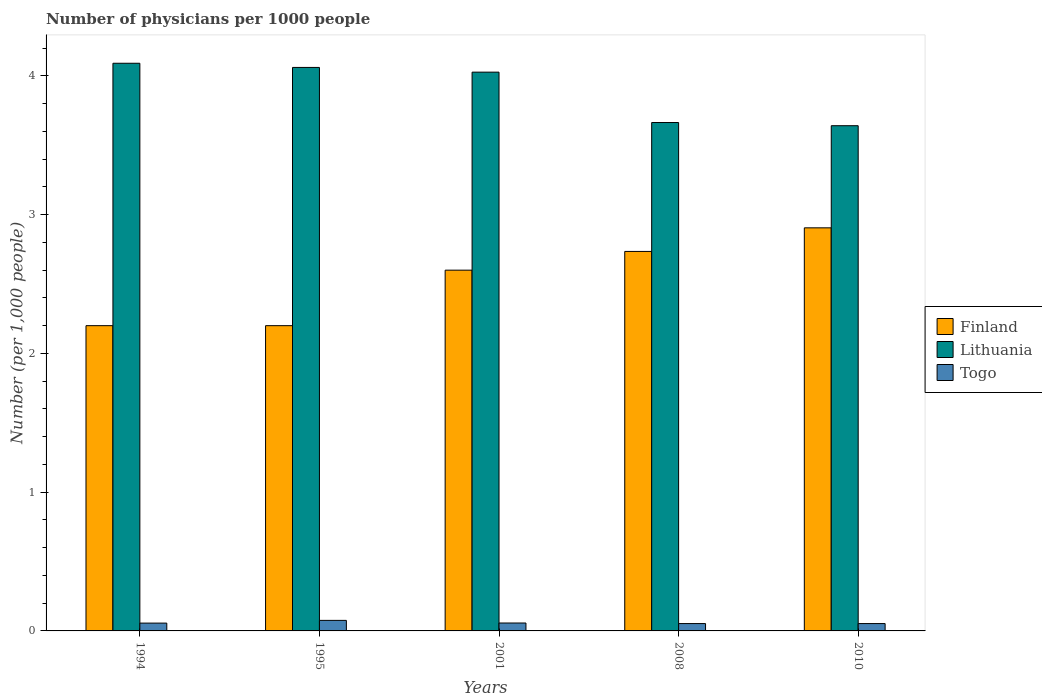How many different coloured bars are there?
Offer a terse response. 3. How many groups of bars are there?
Provide a succinct answer. 5. How many bars are there on the 2nd tick from the right?
Make the answer very short. 3. What is the label of the 4th group of bars from the left?
Keep it short and to the point. 2008. What is the number of physicians in Finland in 2008?
Give a very brief answer. 2.73. Across all years, what is the maximum number of physicians in Finland?
Your response must be concise. 2.9. In which year was the number of physicians in Finland minimum?
Provide a short and direct response. 1994. What is the total number of physicians in Finland in the graph?
Your answer should be compact. 12.64. What is the difference between the number of physicians in Togo in 1995 and that in 2008?
Make the answer very short. 0.02. What is the difference between the number of physicians in Lithuania in 2010 and the number of physicians in Finland in 1995?
Offer a very short reply. 1.44. What is the average number of physicians in Lithuania per year?
Offer a very short reply. 3.9. In the year 2010, what is the difference between the number of physicians in Finland and number of physicians in Lithuania?
Your answer should be very brief. -0.74. What is the ratio of the number of physicians in Finland in 1994 to that in 2001?
Provide a short and direct response. 0.85. What is the difference between the highest and the second highest number of physicians in Finland?
Make the answer very short. 0.17. What is the difference between the highest and the lowest number of physicians in Finland?
Ensure brevity in your answer.  0.7. In how many years, is the number of physicians in Lithuania greater than the average number of physicians in Lithuania taken over all years?
Offer a very short reply. 3. What does the 2nd bar from the left in 2001 represents?
Make the answer very short. Lithuania. Is it the case that in every year, the sum of the number of physicians in Finland and number of physicians in Togo is greater than the number of physicians in Lithuania?
Offer a very short reply. No. Does the graph contain any zero values?
Your answer should be compact. No. Where does the legend appear in the graph?
Make the answer very short. Center right. What is the title of the graph?
Your response must be concise. Number of physicians per 1000 people. What is the label or title of the Y-axis?
Offer a terse response. Number (per 1,0 people). What is the Number (per 1,000 people) in Finland in 1994?
Provide a short and direct response. 2.2. What is the Number (per 1,000 people) in Lithuania in 1994?
Give a very brief answer. 4.09. What is the Number (per 1,000 people) in Togo in 1994?
Keep it short and to the point. 0.06. What is the Number (per 1,000 people) in Lithuania in 1995?
Offer a very short reply. 4.06. What is the Number (per 1,000 people) of Togo in 1995?
Make the answer very short. 0.08. What is the Number (per 1,000 people) of Lithuania in 2001?
Your answer should be very brief. 4.03. What is the Number (per 1,000 people) in Togo in 2001?
Make the answer very short. 0.06. What is the Number (per 1,000 people) of Finland in 2008?
Provide a succinct answer. 2.73. What is the Number (per 1,000 people) of Lithuania in 2008?
Offer a very short reply. 3.66. What is the Number (per 1,000 people) of Togo in 2008?
Offer a very short reply. 0.05. What is the Number (per 1,000 people) in Finland in 2010?
Provide a short and direct response. 2.9. What is the Number (per 1,000 people) in Lithuania in 2010?
Your answer should be compact. 3.64. What is the Number (per 1,000 people) in Togo in 2010?
Ensure brevity in your answer.  0.05. Across all years, what is the maximum Number (per 1,000 people) of Finland?
Make the answer very short. 2.9. Across all years, what is the maximum Number (per 1,000 people) of Lithuania?
Give a very brief answer. 4.09. Across all years, what is the maximum Number (per 1,000 people) of Togo?
Your answer should be compact. 0.08. Across all years, what is the minimum Number (per 1,000 people) of Finland?
Your answer should be compact. 2.2. Across all years, what is the minimum Number (per 1,000 people) of Lithuania?
Provide a short and direct response. 3.64. Across all years, what is the minimum Number (per 1,000 people) of Togo?
Ensure brevity in your answer.  0.05. What is the total Number (per 1,000 people) of Finland in the graph?
Your response must be concise. 12.64. What is the total Number (per 1,000 people) of Lithuania in the graph?
Provide a succinct answer. 19.48. What is the total Number (per 1,000 people) in Togo in the graph?
Make the answer very short. 0.3. What is the difference between the Number (per 1,000 people) in Lithuania in 1994 and that in 1995?
Your response must be concise. 0.03. What is the difference between the Number (per 1,000 people) in Togo in 1994 and that in 1995?
Keep it short and to the point. -0.02. What is the difference between the Number (per 1,000 people) in Lithuania in 1994 and that in 2001?
Offer a very short reply. 0.06. What is the difference between the Number (per 1,000 people) in Togo in 1994 and that in 2001?
Offer a terse response. -0. What is the difference between the Number (per 1,000 people) of Finland in 1994 and that in 2008?
Your answer should be very brief. -0.54. What is the difference between the Number (per 1,000 people) in Lithuania in 1994 and that in 2008?
Ensure brevity in your answer.  0.43. What is the difference between the Number (per 1,000 people) of Togo in 1994 and that in 2008?
Provide a short and direct response. 0. What is the difference between the Number (per 1,000 people) of Finland in 1994 and that in 2010?
Provide a short and direct response. -0.7. What is the difference between the Number (per 1,000 people) of Lithuania in 1994 and that in 2010?
Provide a short and direct response. 0.45. What is the difference between the Number (per 1,000 people) in Togo in 1994 and that in 2010?
Make the answer very short. 0. What is the difference between the Number (per 1,000 people) in Finland in 1995 and that in 2001?
Make the answer very short. -0.4. What is the difference between the Number (per 1,000 people) in Lithuania in 1995 and that in 2001?
Provide a succinct answer. 0.03. What is the difference between the Number (per 1,000 people) in Togo in 1995 and that in 2001?
Give a very brief answer. 0.02. What is the difference between the Number (per 1,000 people) of Finland in 1995 and that in 2008?
Offer a very short reply. -0.54. What is the difference between the Number (per 1,000 people) in Lithuania in 1995 and that in 2008?
Offer a terse response. 0.4. What is the difference between the Number (per 1,000 people) in Togo in 1995 and that in 2008?
Make the answer very short. 0.02. What is the difference between the Number (per 1,000 people) of Finland in 1995 and that in 2010?
Make the answer very short. -0.7. What is the difference between the Number (per 1,000 people) of Lithuania in 1995 and that in 2010?
Offer a terse response. 0.42. What is the difference between the Number (per 1,000 people) of Togo in 1995 and that in 2010?
Provide a succinct answer. 0.02. What is the difference between the Number (per 1,000 people) in Finland in 2001 and that in 2008?
Your answer should be compact. -0.14. What is the difference between the Number (per 1,000 people) in Lithuania in 2001 and that in 2008?
Give a very brief answer. 0.36. What is the difference between the Number (per 1,000 people) in Togo in 2001 and that in 2008?
Your response must be concise. 0. What is the difference between the Number (per 1,000 people) in Finland in 2001 and that in 2010?
Your answer should be very brief. -0.3. What is the difference between the Number (per 1,000 people) in Lithuania in 2001 and that in 2010?
Your response must be concise. 0.39. What is the difference between the Number (per 1,000 people) in Togo in 2001 and that in 2010?
Keep it short and to the point. 0. What is the difference between the Number (per 1,000 people) of Finland in 2008 and that in 2010?
Give a very brief answer. -0.17. What is the difference between the Number (per 1,000 people) of Lithuania in 2008 and that in 2010?
Offer a very short reply. 0.02. What is the difference between the Number (per 1,000 people) of Finland in 1994 and the Number (per 1,000 people) of Lithuania in 1995?
Your answer should be very brief. -1.86. What is the difference between the Number (per 1,000 people) in Finland in 1994 and the Number (per 1,000 people) in Togo in 1995?
Ensure brevity in your answer.  2.12. What is the difference between the Number (per 1,000 people) in Lithuania in 1994 and the Number (per 1,000 people) in Togo in 1995?
Your answer should be very brief. 4.02. What is the difference between the Number (per 1,000 people) in Finland in 1994 and the Number (per 1,000 people) in Lithuania in 2001?
Give a very brief answer. -1.83. What is the difference between the Number (per 1,000 people) in Finland in 1994 and the Number (per 1,000 people) in Togo in 2001?
Your answer should be compact. 2.14. What is the difference between the Number (per 1,000 people) in Lithuania in 1994 and the Number (per 1,000 people) in Togo in 2001?
Offer a terse response. 4.03. What is the difference between the Number (per 1,000 people) in Finland in 1994 and the Number (per 1,000 people) in Lithuania in 2008?
Provide a succinct answer. -1.46. What is the difference between the Number (per 1,000 people) in Finland in 1994 and the Number (per 1,000 people) in Togo in 2008?
Ensure brevity in your answer.  2.15. What is the difference between the Number (per 1,000 people) of Lithuania in 1994 and the Number (per 1,000 people) of Togo in 2008?
Provide a short and direct response. 4.04. What is the difference between the Number (per 1,000 people) in Finland in 1994 and the Number (per 1,000 people) in Lithuania in 2010?
Make the answer very short. -1.44. What is the difference between the Number (per 1,000 people) of Finland in 1994 and the Number (per 1,000 people) of Togo in 2010?
Keep it short and to the point. 2.15. What is the difference between the Number (per 1,000 people) in Lithuania in 1994 and the Number (per 1,000 people) in Togo in 2010?
Give a very brief answer. 4.04. What is the difference between the Number (per 1,000 people) in Finland in 1995 and the Number (per 1,000 people) in Lithuania in 2001?
Provide a short and direct response. -1.83. What is the difference between the Number (per 1,000 people) of Finland in 1995 and the Number (per 1,000 people) of Togo in 2001?
Give a very brief answer. 2.14. What is the difference between the Number (per 1,000 people) of Lithuania in 1995 and the Number (per 1,000 people) of Togo in 2001?
Your answer should be compact. 4. What is the difference between the Number (per 1,000 people) in Finland in 1995 and the Number (per 1,000 people) in Lithuania in 2008?
Ensure brevity in your answer.  -1.46. What is the difference between the Number (per 1,000 people) of Finland in 1995 and the Number (per 1,000 people) of Togo in 2008?
Provide a short and direct response. 2.15. What is the difference between the Number (per 1,000 people) in Lithuania in 1995 and the Number (per 1,000 people) in Togo in 2008?
Provide a succinct answer. 4.01. What is the difference between the Number (per 1,000 people) of Finland in 1995 and the Number (per 1,000 people) of Lithuania in 2010?
Your answer should be compact. -1.44. What is the difference between the Number (per 1,000 people) of Finland in 1995 and the Number (per 1,000 people) of Togo in 2010?
Give a very brief answer. 2.15. What is the difference between the Number (per 1,000 people) in Lithuania in 1995 and the Number (per 1,000 people) in Togo in 2010?
Your response must be concise. 4.01. What is the difference between the Number (per 1,000 people) of Finland in 2001 and the Number (per 1,000 people) of Lithuania in 2008?
Your answer should be very brief. -1.06. What is the difference between the Number (per 1,000 people) of Finland in 2001 and the Number (per 1,000 people) of Togo in 2008?
Your answer should be compact. 2.55. What is the difference between the Number (per 1,000 people) of Lithuania in 2001 and the Number (per 1,000 people) of Togo in 2008?
Your answer should be compact. 3.97. What is the difference between the Number (per 1,000 people) in Finland in 2001 and the Number (per 1,000 people) in Lithuania in 2010?
Your answer should be very brief. -1.04. What is the difference between the Number (per 1,000 people) of Finland in 2001 and the Number (per 1,000 people) of Togo in 2010?
Give a very brief answer. 2.55. What is the difference between the Number (per 1,000 people) in Lithuania in 2001 and the Number (per 1,000 people) in Togo in 2010?
Make the answer very short. 3.97. What is the difference between the Number (per 1,000 people) in Finland in 2008 and the Number (per 1,000 people) in Lithuania in 2010?
Your answer should be very brief. -0.91. What is the difference between the Number (per 1,000 people) of Finland in 2008 and the Number (per 1,000 people) of Togo in 2010?
Provide a succinct answer. 2.68. What is the difference between the Number (per 1,000 people) of Lithuania in 2008 and the Number (per 1,000 people) of Togo in 2010?
Your answer should be compact. 3.61. What is the average Number (per 1,000 people) of Finland per year?
Offer a very short reply. 2.53. What is the average Number (per 1,000 people) in Lithuania per year?
Keep it short and to the point. 3.9. What is the average Number (per 1,000 people) in Togo per year?
Your answer should be very brief. 0.06. In the year 1994, what is the difference between the Number (per 1,000 people) of Finland and Number (per 1,000 people) of Lithuania?
Offer a terse response. -1.89. In the year 1994, what is the difference between the Number (per 1,000 people) in Finland and Number (per 1,000 people) in Togo?
Your answer should be compact. 2.14. In the year 1994, what is the difference between the Number (per 1,000 people) of Lithuania and Number (per 1,000 people) of Togo?
Ensure brevity in your answer.  4.03. In the year 1995, what is the difference between the Number (per 1,000 people) in Finland and Number (per 1,000 people) in Lithuania?
Ensure brevity in your answer.  -1.86. In the year 1995, what is the difference between the Number (per 1,000 people) of Finland and Number (per 1,000 people) of Togo?
Make the answer very short. 2.12. In the year 1995, what is the difference between the Number (per 1,000 people) of Lithuania and Number (per 1,000 people) of Togo?
Provide a succinct answer. 3.98. In the year 2001, what is the difference between the Number (per 1,000 people) of Finland and Number (per 1,000 people) of Lithuania?
Ensure brevity in your answer.  -1.43. In the year 2001, what is the difference between the Number (per 1,000 people) in Finland and Number (per 1,000 people) in Togo?
Your answer should be very brief. 2.54. In the year 2001, what is the difference between the Number (per 1,000 people) of Lithuania and Number (per 1,000 people) of Togo?
Provide a short and direct response. 3.97. In the year 2008, what is the difference between the Number (per 1,000 people) of Finland and Number (per 1,000 people) of Lithuania?
Make the answer very short. -0.93. In the year 2008, what is the difference between the Number (per 1,000 people) in Finland and Number (per 1,000 people) in Togo?
Keep it short and to the point. 2.68. In the year 2008, what is the difference between the Number (per 1,000 people) of Lithuania and Number (per 1,000 people) of Togo?
Make the answer very short. 3.61. In the year 2010, what is the difference between the Number (per 1,000 people) in Finland and Number (per 1,000 people) in Lithuania?
Your response must be concise. -0.74. In the year 2010, what is the difference between the Number (per 1,000 people) in Finland and Number (per 1,000 people) in Togo?
Your answer should be very brief. 2.85. In the year 2010, what is the difference between the Number (per 1,000 people) in Lithuania and Number (per 1,000 people) in Togo?
Offer a very short reply. 3.59. What is the ratio of the Number (per 1,000 people) in Finland in 1994 to that in 1995?
Provide a short and direct response. 1. What is the ratio of the Number (per 1,000 people) of Lithuania in 1994 to that in 1995?
Make the answer very short. 1.01. What is the ratio of the Number (per 1,000 people) in Togo in 1994 to that in 1995?
Give a very brief answer. 0.74. What is the ratio of the Number (per 1,000 people) in Finland in 1994 to that in 2001?
Give a very brief answer. 0.85. What is the ratio of the Number (per 1,000 people) of Lithuania in 1994 to that in 2001?
Keep it short and to the point. 1.02. What is the ratio of the Number (per 1,000 people) in Finland in 1994 to that in 2008?
Provide a succinct answer. 0.8. What is the ratio of the Number (per 1,000 people) in Lithuania in 1994 to that in 2008?
Give a very brief answer. 1.12. What is the ratio of the Number (per 1,000 people) in Togo in 1994 to that in 2008?
Make the answer very short. 1.06. What is the ratio of the Number (per 1,000 people) in Finland in 1994 to that in 2010?
Your response must be concise. 0.76. What is the ratio of the Number (per 1,000 people) of Lithuania in 1994 to that in 2010?
Offer a very short reply. 1.12. What is the ratio of the Number (per 1,000 people) of Togo in 1994 to that in 2010?
Provide a succinct answer. 1.06. What is the ratio of the Number (per 1,000 people) in Finland in 1995 to that in 2001?
Your answer should be compact. 0.85. What is the ratio of the Number (per 1,000 people) of Lithuania in 1995 to that in 2001?
Offer a very short reply. 1.01. What is the ratio of the Number (per 1,000 people) of Togo in 1995 to that in 2001?
Offer a terse response. 1.33. What is the ratio of the Number (per 1,000 people) in Finland in 1995 to that in 2008?
Keep it short and to the point. 0.8. What is the ratio of the Number (per 1,000 people) in Lithuania in 1995 to that in 2008?
Offer a very short reply. 1.11. What is the ratio of the Number (per 1,000 people) in Togo in 1995 to that in 2008?
Your answer should be compact. 1.43. What is the ratio of the Number (per 1,000 people) of Finland in 1995 to that in 2010?
Provide a succinct answer. 0.76. What is the ratio of the Number (per 1,000 people) in Lithuania in 1995 to that in 2010?
Your answer should be compact. 1.12. What is the ratio of the Number (per 1,000 people) of Togo in 1995 to that in 2010?
Your answer should be very brief. 1.43. What is the ratio of the Number (per 1,000 people) of Finland in 2001 to that in 2008?
Make the answer very short. 0.95. What is the ratio of the Number (per 1,000 people) of Lithuania in 2001 to that in 2008?
Ensure brevity in your answer.  1.1. What is the ratio of the Number (per 1,000 people) of Togo in 2001 to that in 2008?
Provide a short and direct response. 1.08. What is the ratio of the Number (per 1,000 people) of Finland in 2001 to that in 2010?
Offer a terse response. 0.9. What is the ratio of the Number (per 1,000 people) in Lithuania in 2001 to that in 2010?
Give a very brief answer. 1.11. What is the ratio of the Number (per 1,000 people) of Togo in 2001 to that in 2010?
Your response must be concise. 1.08. What is the ratio of the Number (per 1,000 people) in Finland in 2008 to that in 2010?
Offer a very short reply. 0.94. What is the ratio of the Number (per 1,000 people) in Lithuania in 2008 to that in 2010?
Ensure brevity in your answer.  1.01. What is the difference between the highest and the second highest Number (per 1,000 people) in Finland?
Offer a very short reply. 0.17. What is the difference between the highest and the second highest Number (per 1,000 people) of Lithuania?
Keep it short and to the point. 0.03. What is the difference between the highest and the second highest Number (per 1,000 people) in Togo?
Give a very brief answer. 0.02. What is the difference between the highest and the lowest Number (per 1,000 people) of Finland?
Keep it short and to the point. 0.7. What is the difference between the highest and the lowest Number (per 1,000 people) in Lithuania?
Provide a succinct answer. 0.45. What is the difference between the highest and the lowest Number (per 1,000 people) in Togo?
Provide a short and direct response. 0.02. 